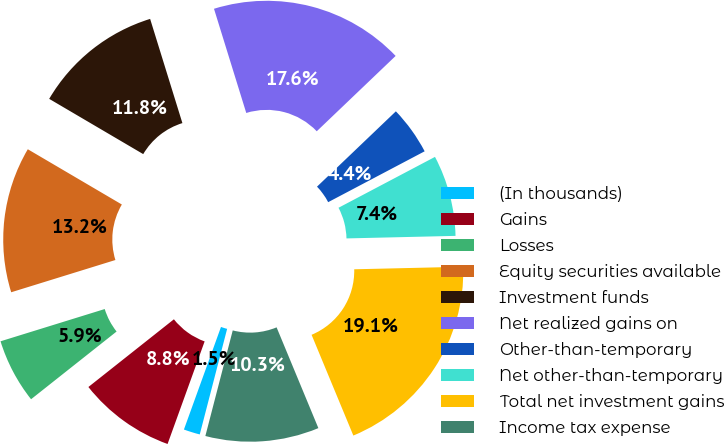Convert chart to OTSL. <chart><loc_0><loc_0><loc_500><loc_500><pie_chart><fcel>(In thousands)<fcel>Gains<fcel>Losses<fcel>Equity securities available<fcel>Investment funds<fcel>Net realized gains on<fcel>Other-than-temporary<fcel>Net other-than-temporary<fcel>Total net investment gains<fcel>Income tax expense<nl><fcel>1.48%<fcel>8.82%<fcel>5.88%<fcel>13.23%<fcel>11.76%<fcel>17.64%<fcel>4.41%<fcel>7.35%<fcel>19.11%<fcel>10.29%<nl></chart> 